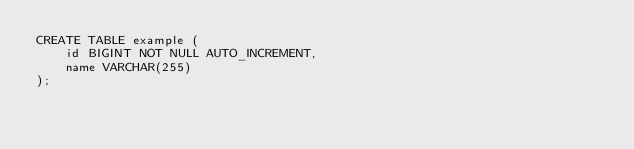<code> <loc_0><loc_0><loc_500><loc_500><_SQL_>CREATE TABLE example (
    id BIGINT NOT NULL AUTO_INCREMENT,
    name VARCHAR(255)
);
</code> 